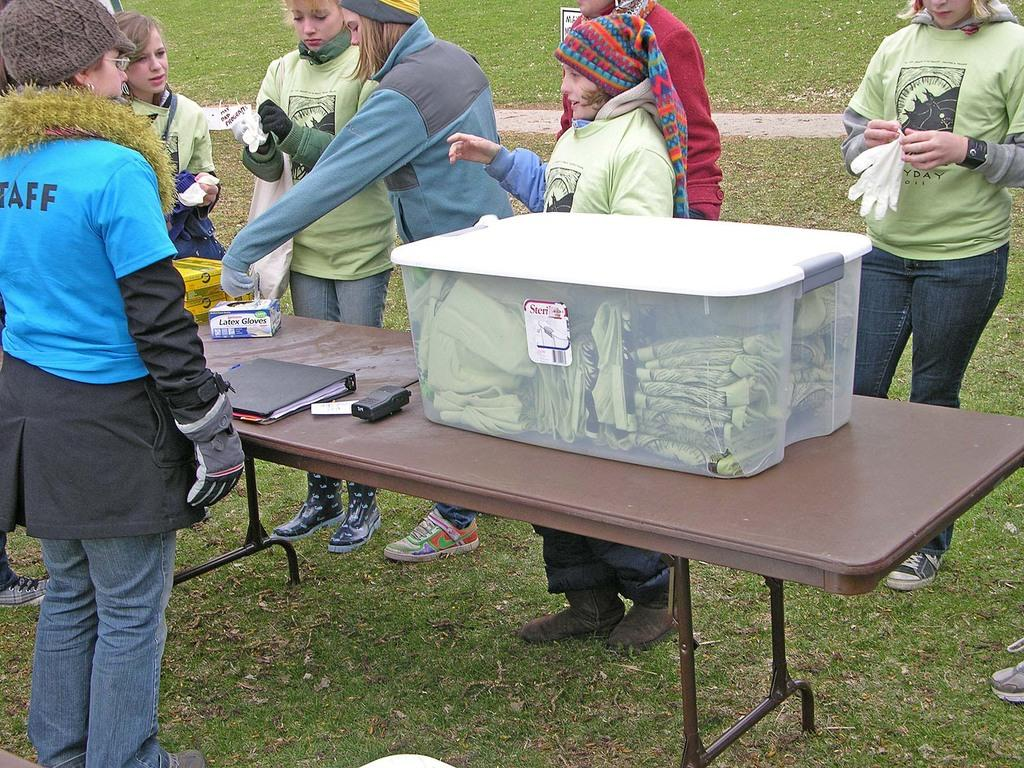What are the people in the image doing? The people in the image are standing on the grass. What other objects can be seen in the image? There is a table in the image. What is on the table? There is a box on the table. What is inside the box? The box contains t-shirts. What color is the paint on the silver t-shirts in the image? There is no paint or silver t-shirts present in the image; the box contains t-shirts. 